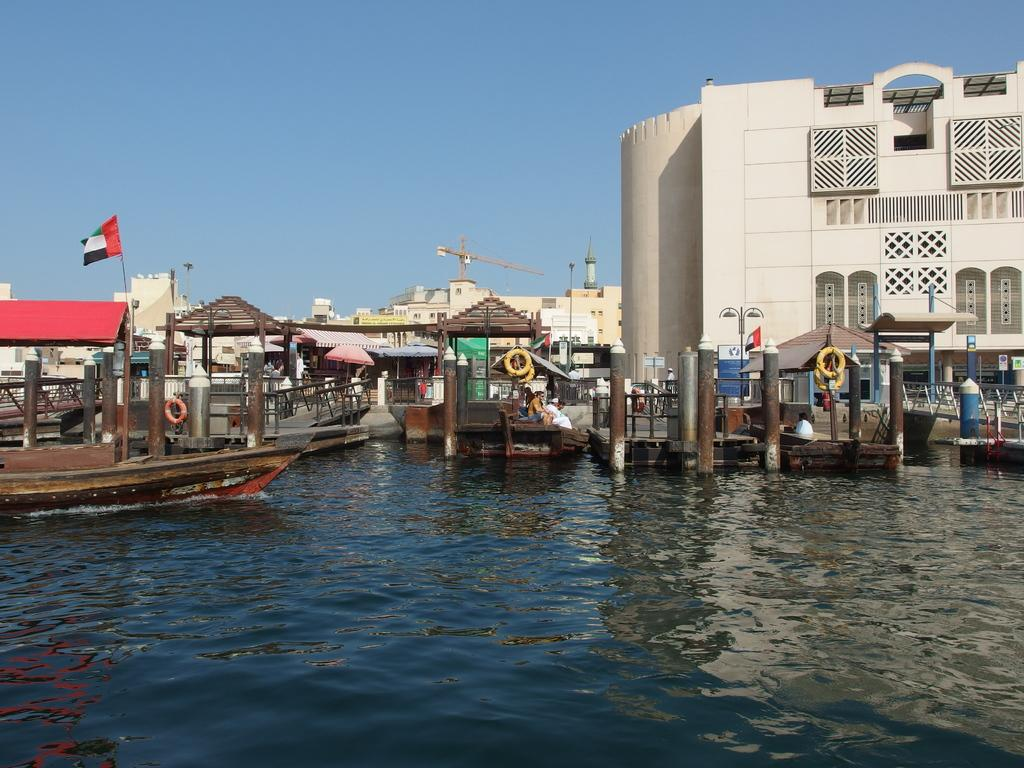What is the main subject of the image? The main subject of the image is water. What can be seen in the water? There are boats in the water. What structure is located on the right side of the image? There is a building on the right side of the image. What is visible at the top of the image? The sky is visible at the top of the image. Who is the spy that can be seen leading the boats in the image? There is no spy or any indication of leadership in the image; it simply shows boats in the water. What rule is being enforced by the person standing on the building in the image? There is no person standing on the building in the image, and no rules are being enforced. 